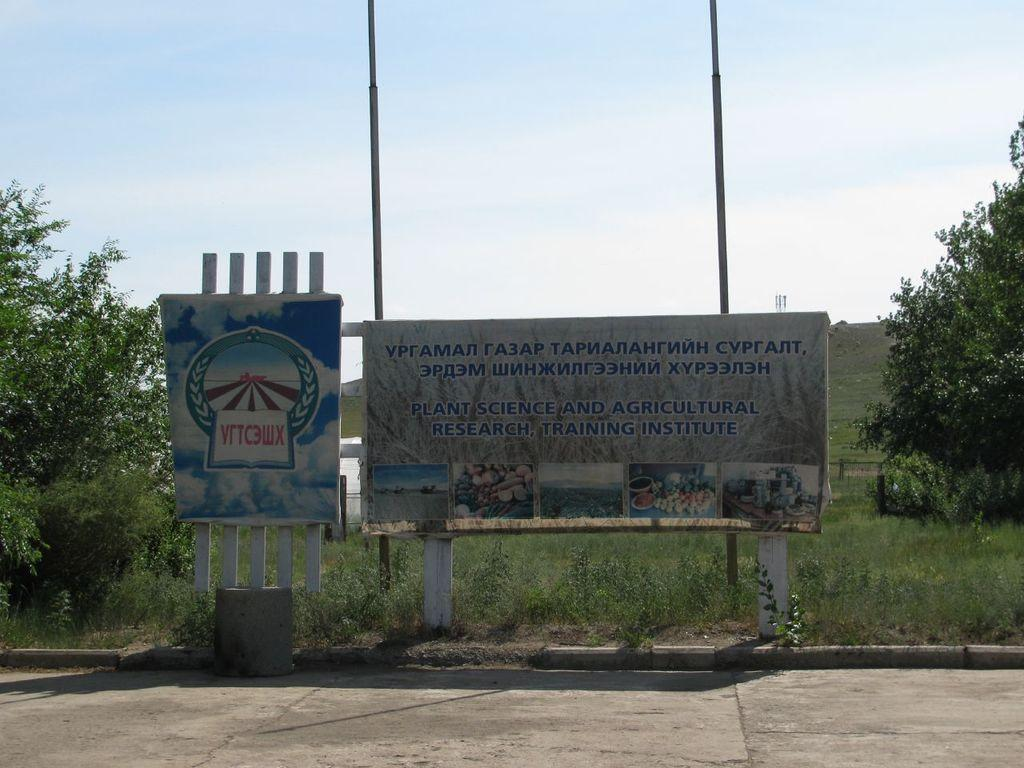What type of structure is visible in the image? There are boards with poles in the image. What type of vegetation can be seen in the image? There are plants, grass, and trees in the image. What type of path is present in the image? There is a walkway at the bottom of the image. What is visible in the background of the image? The sky is visible in the background of the image. What type of creature is providing the answer to the question in the image? There is no creature present in the image, nor is there any question or answer being provided. What type of punishment is being administered to the plants in the image? There is no punishment being administered to the plants in the image; they are simply growing in their natural environment. 